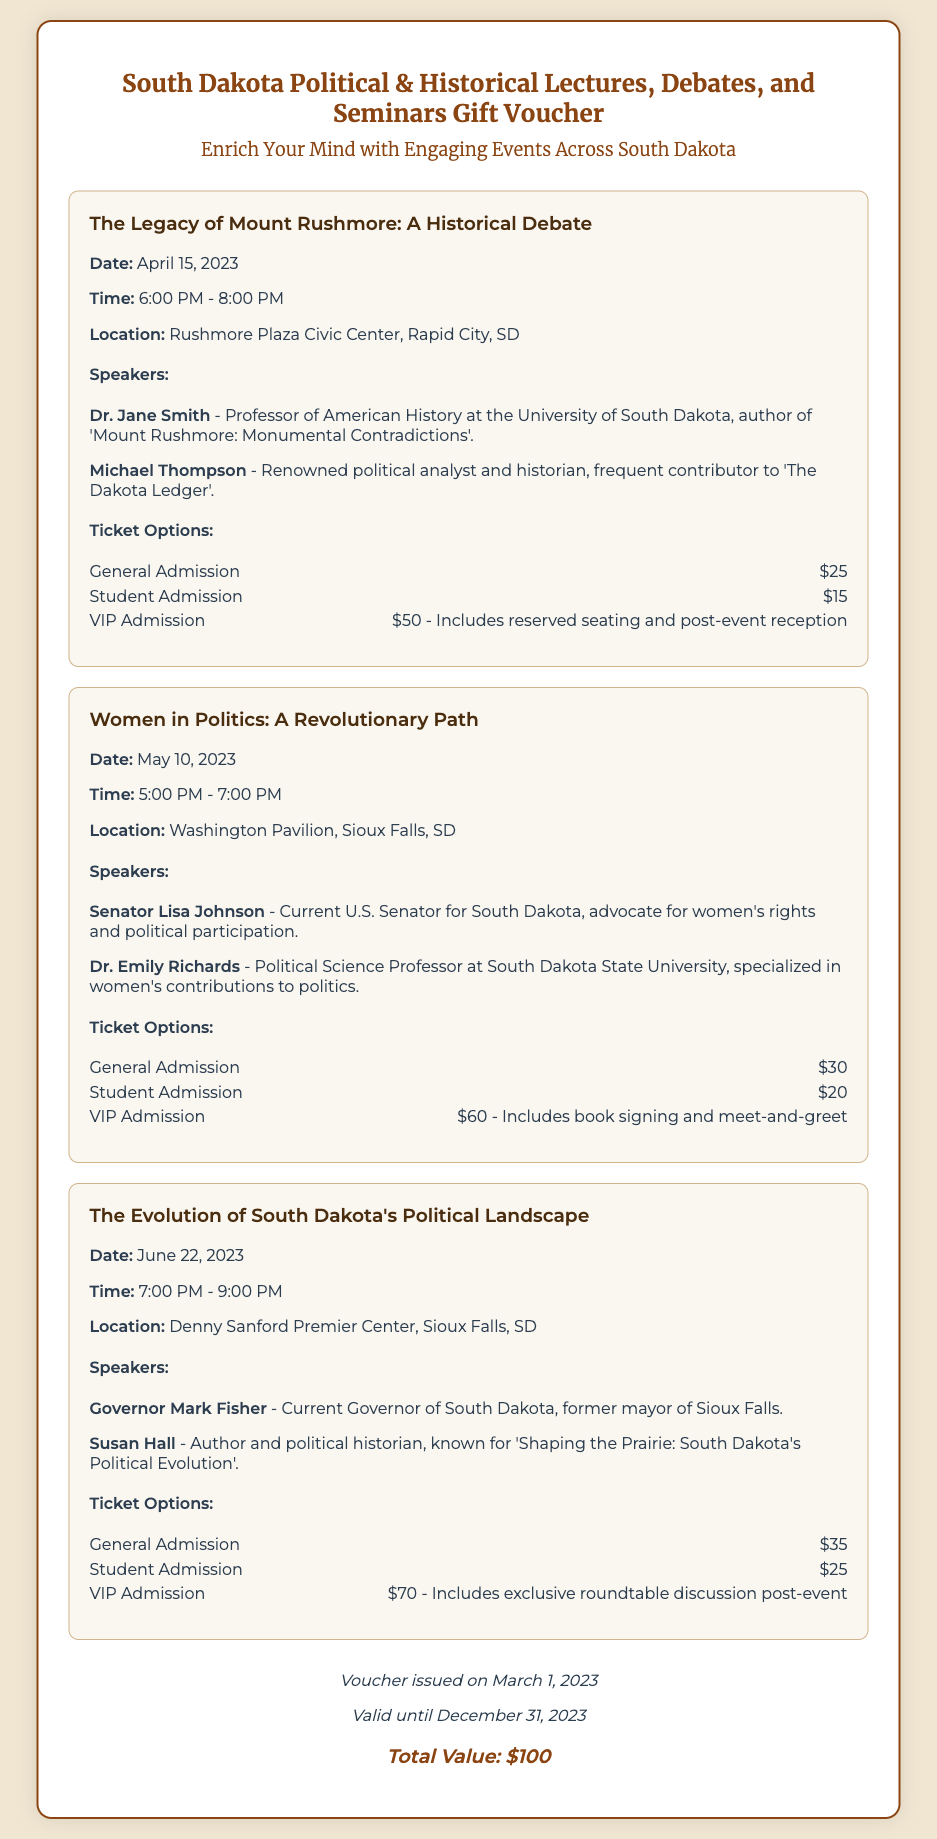What is the date of the event "The Legacy of Mount Rushmore: A Historical Debate"? The date is explicitly mentioned in the event details section of the document as April 15, 2023.
Answer: April 15, 2023 Who is the first speaker listed for "Women in Politics: A Revolutionary Path"? The first speaker is outlined in the speaker bios section for the event and is Senator Lisa Johnson.
Answer: Senator Lisa Johnson What is the location for the event on June 22, 2023? The location is included in the event details for "The Evolution of South Dakota's Political Landscape" and is the Denny Sanford Premier Center.
Answer: Denny Sanford Premier Center How much does VIP Admission cost for "The Evolution of South Dakota's Political Landscape"? The price for VIP Admission is noted in the ticket types section of the event as $70.
Answer: $70 What is the total value of the gift voucher? The total value is indicated at the bottom of the document in the voucher details section, which states $100.
Answer: $100 